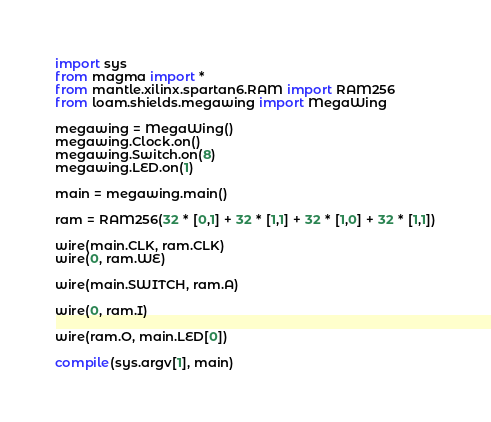<code> <loc_0><loc_0><loc_500><loc_500><_Python_>import sys
from magma import *
from mantle.xilinx.spartan6.RAM import RAM256
from loam.shields.megawing import MegaWing

megawing = MegaWing()
megawing.Clock.on()
megawing.Switch.on(8)
megawing.LED.on(1)

main = megawing.main()

ram = RAM256(32 * [0,1] + 32 * [1,1] + 32 * [1,0] + 32 * [1,1])

wire(main.CLK, ram.CLK)
wire(0, ram.WE)

wire(main.SWITCH, ram.A)

wire(0, ram.I)

wire(ram.O, main.LED[0])

compile(sys.argv[1], main)
</code> 